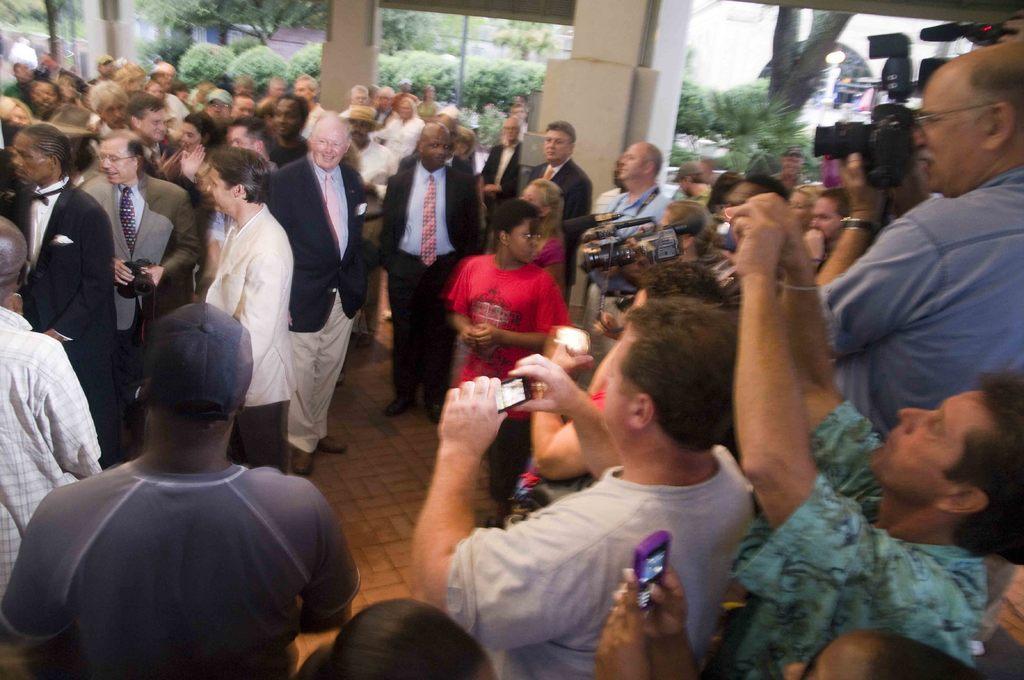Describe this image in one or two sentences. In the center of the image there are many people. In the background of the image there are trees. 